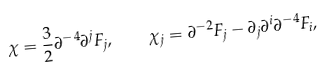<formula> <loc_0><loc_0><loc_500><loc_500>\chi = \frac { 3 } { 2 } \partial ^ { - 4 } \partial ^ { j } F _ { j } , \quad \chi _ { j } = \partial ^ { - 2 } F _ { j } - \partial _ { j } \partial ^ { i } \partial ^ { - 4 } F _ { i } ,</formula> 